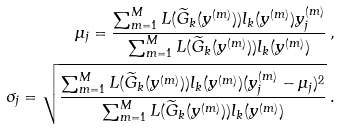<formula> <loc_0><loc_0><loc_500><loc_500>\mu _ { j } = \frac { \sum ^ { M } _ { m = 1 } L ( \widetilde { G } _ { k } ( y ^ { ( m ) } ) ) l _ { k } ( y ^ { ( m ) } ) y ^ { ( m ) } _ { j } } { \sum ^ { M } _ { m = 1 } L ( \widetilde { G } _ { k } ( y ^ { ( m ) } ) ) l _ { k } ( y ^ { ( m ) } ) } \, , \\ { \sigma _ { j } } = \sqrt { \frac { \sum ^ { M } _ { m = 1 } L ( \widetilde { G } _ { k } ( y ^ { ( m ) } ) ) l _ { k } ( y ^ { ( m ) } ) ( y ^ { ( m ) } _ { j } - \mu _ { j } ) ^ { 2 } } { \sum ^ { M } _ { m = 1 } L ( \widetilde { G } _ { k } ( y ^ { ( m ) } ) ) l _ { k } ( y ^ { ( m ) } ) } } \, .</formula> 